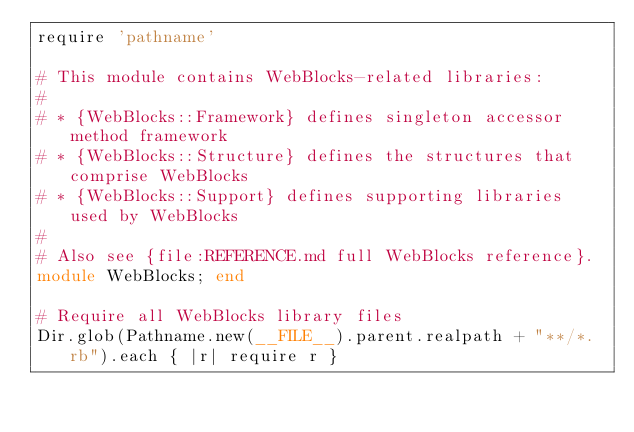Convert code to text. <code><loc_0><loc_0><loc_500><loc_500><_Ruby_>require 'pathname'

# This module contains WebBlocks-related libraries:
#
# * {WebBlocks::Framework} defines singleton accessor method framework
# * {WebBlocks::Structure} defines the structures that comprise WebBlocks
# * {WebBlocks::Support} defines supporting libraries used by WebBlocks
#
# Also see {file:REFERENCE.md full WebBlocks reference}.
module WebBlocks; end

# Require all WebBlocks library files
Dir.glob(Pathname.new(__FILE__).parent.realpath + "**/*.rb").each { |r| require r }</code> 